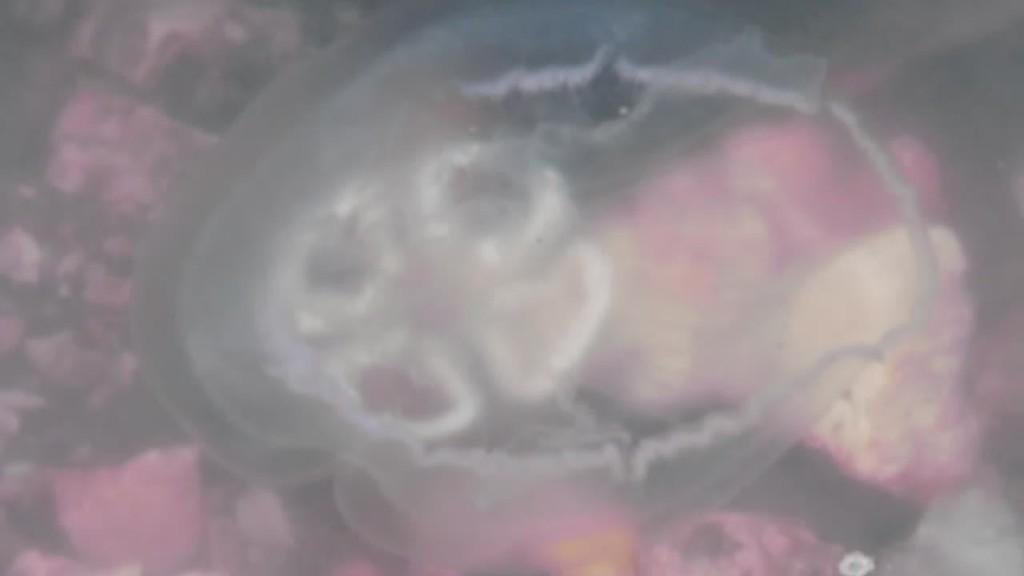Please provide a concise description of this image. In this image there are biological tissues which are visible. 